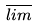Convert formula to latex. <formula><loc_0><loc_0><loc_500><loc_500>\overline { l i m }</formula> 